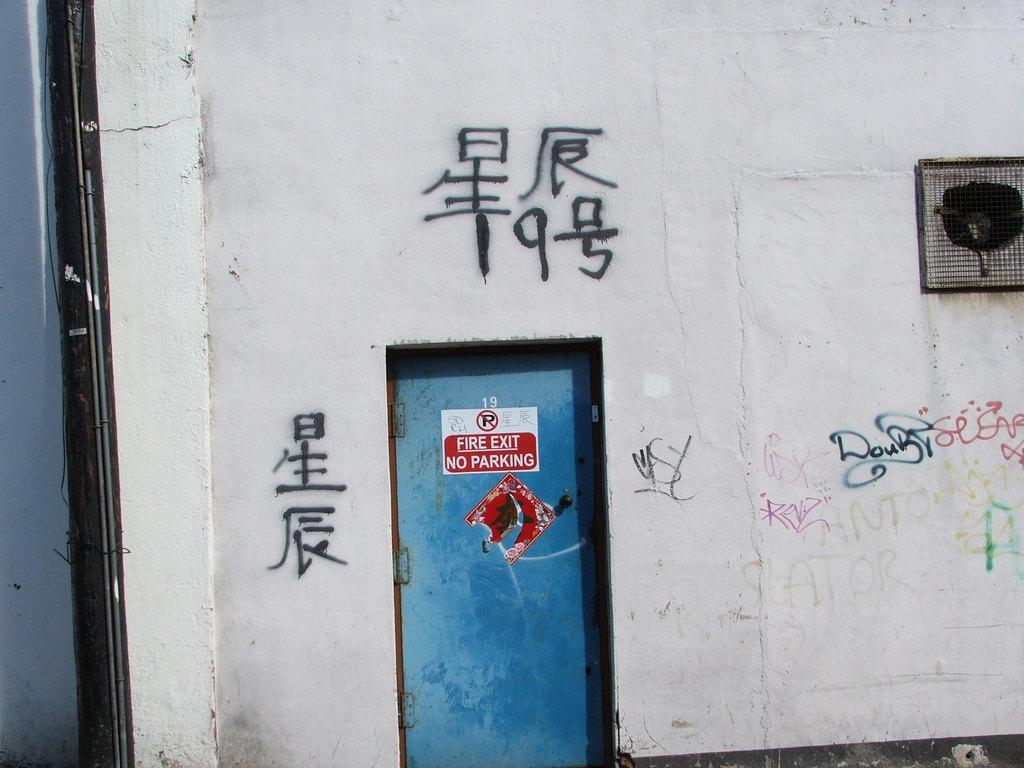What type of artwork can be seen on the wall in the image? There are paintings on a wall in the image. What architectural feature is present in the image? There is a door in the image. What color is the door? The door is blue. What type of ventilation system is visible in the image? There is a heat exhaust in the image. Can you see any fangs in the image? There are no fangs present in the image. Is there a water source visible in the image? There is no water source visible in the image. 